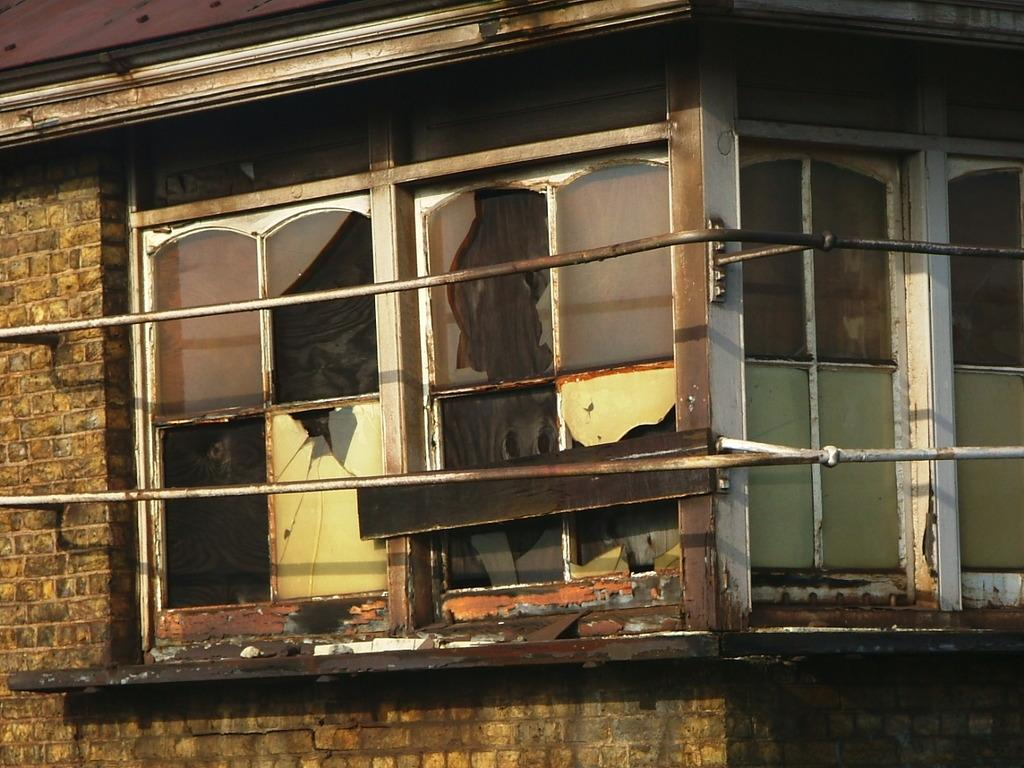What type of structure is present in the image? There is a house in the image. What feature can be seen on the house? The house has windows. What type of debris is visible in the image? There is broken glass in the image. How many rabbits can be seen playing around the house in the image? There are no rabbits present in the image. What type of waterfowl is visible in the image? There is no duck present in the image. 